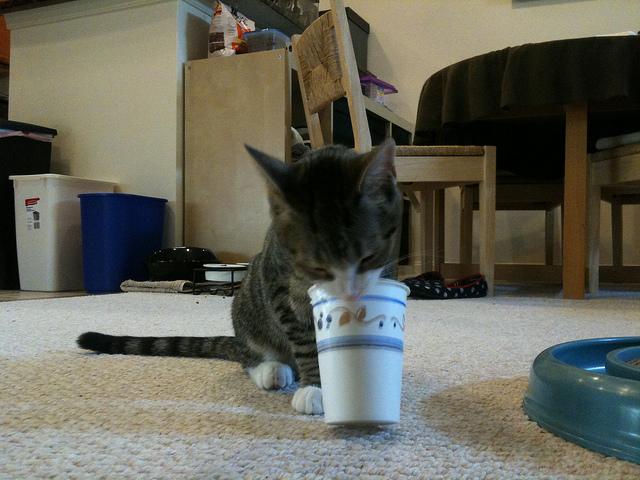Why aren't the cat's feet visible?
Write a very short answer. Cup. What color is the cat's collar?
Short answer required. Black. What is the cat looking at?
Concise answer only. Cup. Has the carpet been vacuumed recently?
Concise answer only. Yes. How many trash cans do you see?
Give a very brief answer. 3. What is the kitten chewing on?
Concise answer only. Cup. Is a cat toy in the picture?
Write a very short answer. No. 